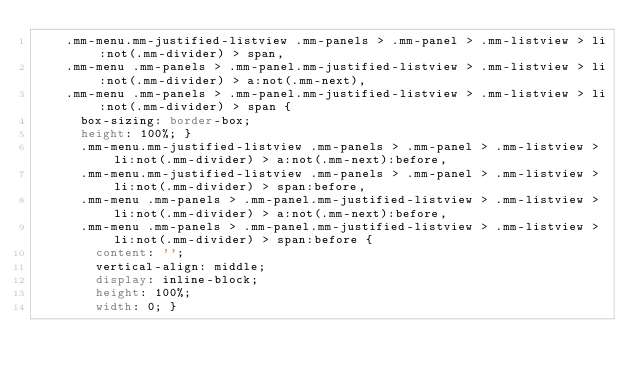Convert code to text. <code><loc_0><loc_0><loc_500><loc_500><_CSS_>    .mm-menu.mm-justified-listview .mm-panels > .mm-panel > .mm-listview > li:not(.mm-divider) > span,
    .mm-menu .mm-panels > .mm-panel.mm-justified-listview > .mm-listview > li:not(.mm-divider) > a:not(.mm-next),
    .mm-menu .mm-panels > .mm-panel.mm-justified-listview > .mm-listview > li:not(.mm-divider) > span {
      box-sizing: border-box;
      height: 100%; }
      .mm-menu.mm-justified-listview .mm-panels > .mm-panel > .mm-listview > li:not(.mm-divider) > a:not(.mm-next):before,
      .mm-menu.mm-justified-listview .mm-panels > .mm-panel > .mm-listview > li:not(.mm-divider) > span:before,
      .mm-menu .mm-panels > .mm-panel.mm-justified-listview > .mm-listview > li:not(.mm-divider) > a:not(.mm-next):before,
      .mm-menu .mm-panels > .mm-panel.mm-justified-listview > .mm-listview > li:not(.mm-divider) > span:before {
        content: '';
        vertical-align: middle;
        display: inline-block;
        height: 100%;
        width: 0; }
</code> 